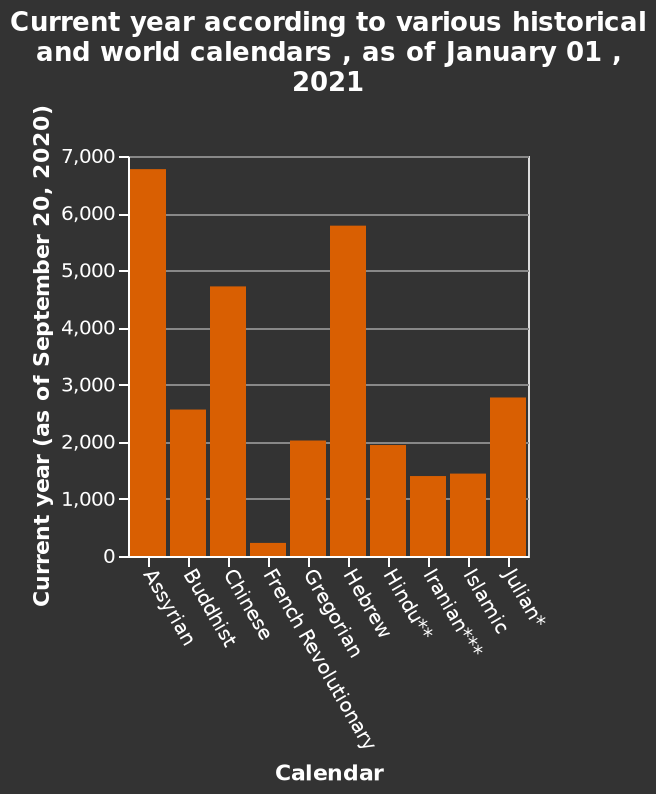<image>
During which event did the French Revolution occur?  The French Revolution occurred around year 300. please enumerates aspects of the construction of the chart Current year according to various historical and world calendars , as of January 01 , 2021 is a bar diagram. On the y-axis, Current year (as of September 20, 2020) is measured. A categorical scale from Assyrian to Julian* can be found on the x-axis, marked Calendar. 